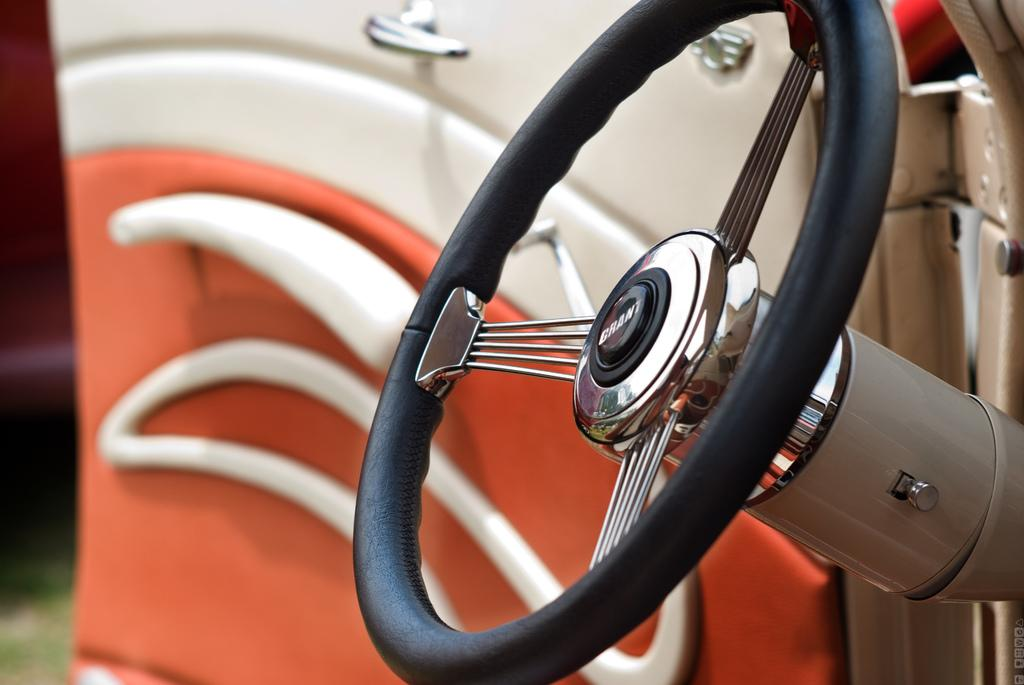What is the main object in the image? The main object in the image is the steering wheel of a car. What else can be seen in the image related to the car? The car door is visible in the image. What colors are present on the car door? The car door is in white and red color. What type of drink is being served in the car's engine in the image? There is no drink or engine present in the image; it only contains the steering wheel and car door. 